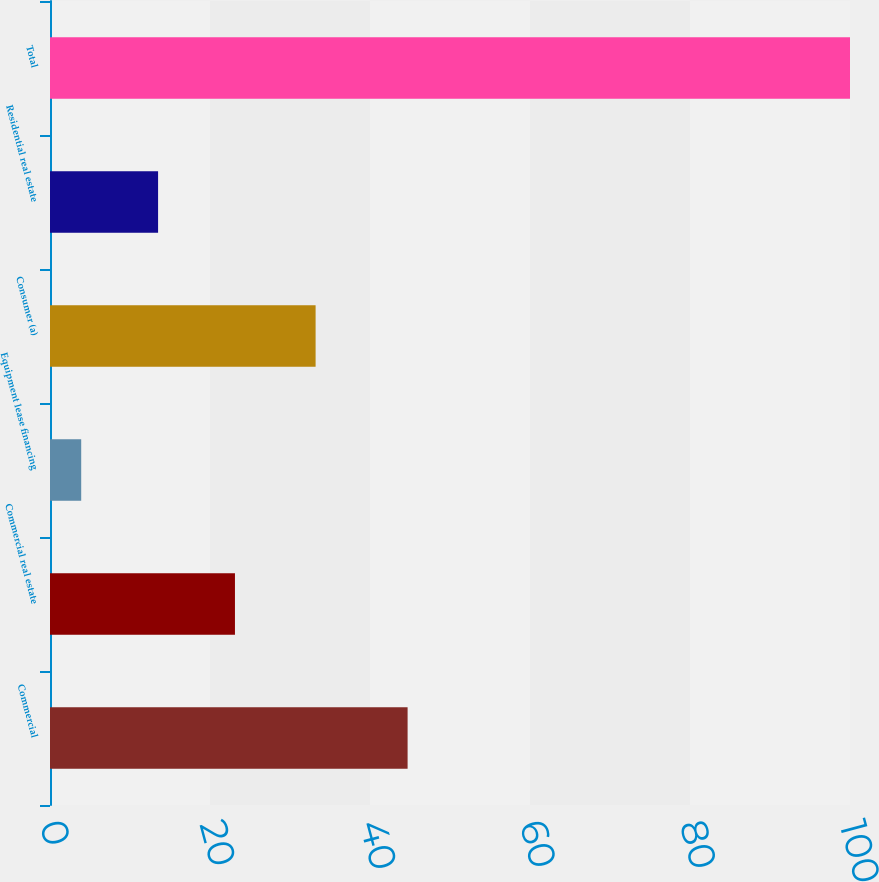Convert chart to OTSL. <chart><loc_0><loc_0><loc_500><loc_500><bar_chart><fcel>Commercial<fcel>Commercial real estate<fcel>Equipment lease financing<fcel>Consumer (a)<fcel>Residential real estate<fcel>Total<nl><fcel>44.7<fcel>23.12<fcel>3.9<fcel>33.2<fcel>13.51<fcel>100<nl></chart> 